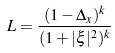Convert formula to latex. <formula><loc_0><loc_0><loc_500><loc_500>L = \frac { ( 1 - \Delta _ { x } ) ^ { k } } { ( 1 + | \xi | ^ { 2 } ) ^ { k } }</formula> 